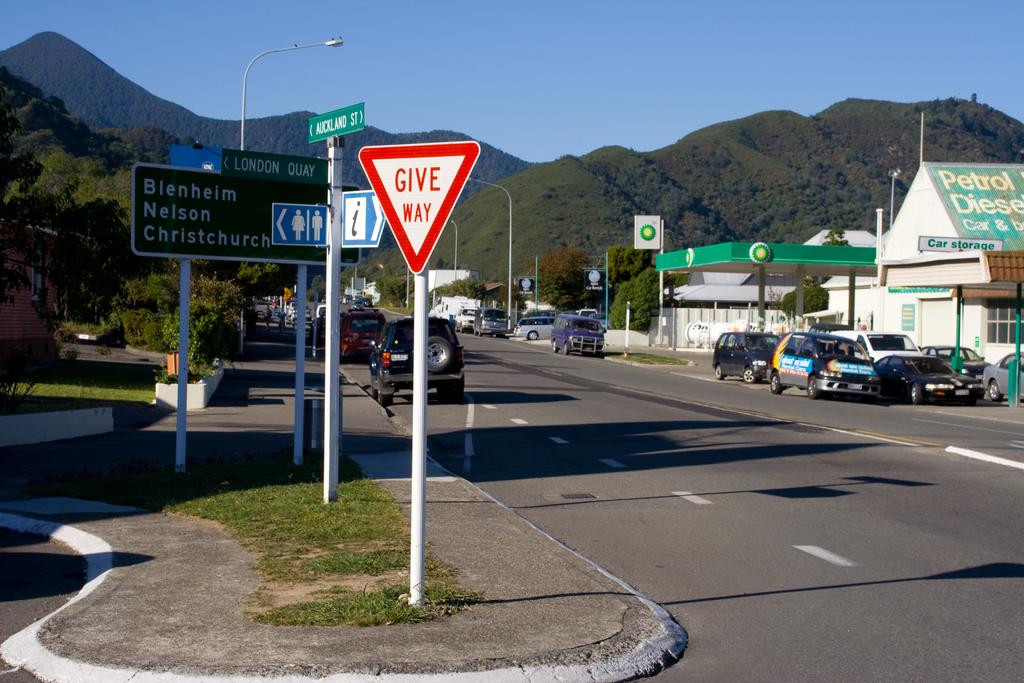What is the red and white sign instructing?
Provide a succinct answer. Give way. 